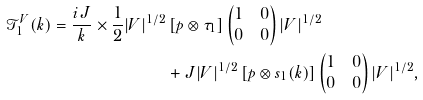Convert formula to latex. <formula><loc_0><loc_0><loc_500><loc_500>\mathcal { T } _ { 1 } ^ { V } ( k ) = \frac { i J } { k } \times \frac { 1 } { 2 } | V | ^ { 1 / 2 } & \left [ p \otimes \tau _ { 1 } \right ] \begin{pmatrix} 1 & 0 \\ 0 & 0 \end{pmatrix} | V | ^ { 1 / 2 } \\ & + J | V | ^ { 1 / 2 } \left [ p \otimes s _ { 1 } ( k ) \right ] \begin{pmatrix} 1 & 0 \\ 0 & 0 \end{pmatrix} | V | ^ { 1 / 2 } ,</formula> 